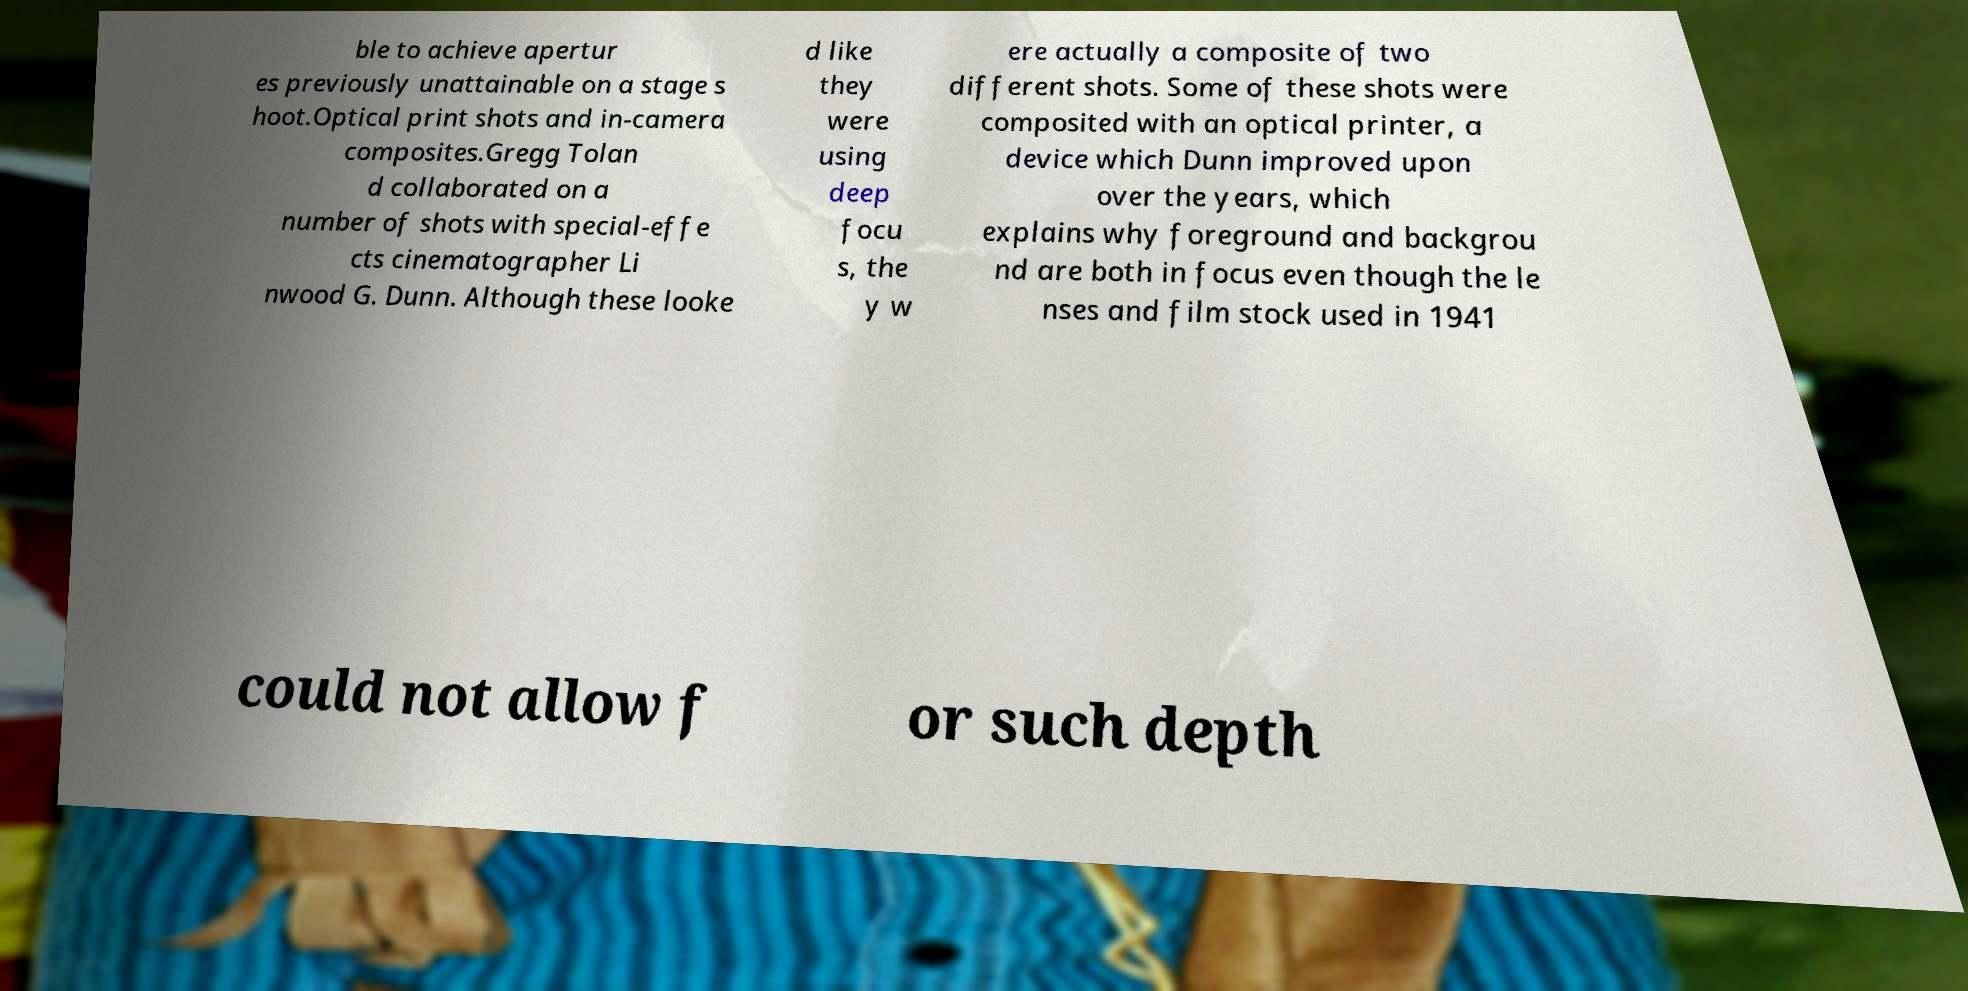Could you extract and type out the text from this image? ble to achieve apertur es previously unattainable on a stage s hoot.Optical print shots and in-camera composites.Gregg Tolan d collaborated on a number of shots with special-effe cts cinematographer Li nwood G. Dunn. Although these looke d like they were using deep focu s, the y w ere actually a composite of two different shots. Some of these shots were composited with an optical printer, a device which Dunn improved upon over the years, which explains why foreground and backgrou nd are both in focus even though the le nses and film stock used in 1941 could not allow f or such depth 